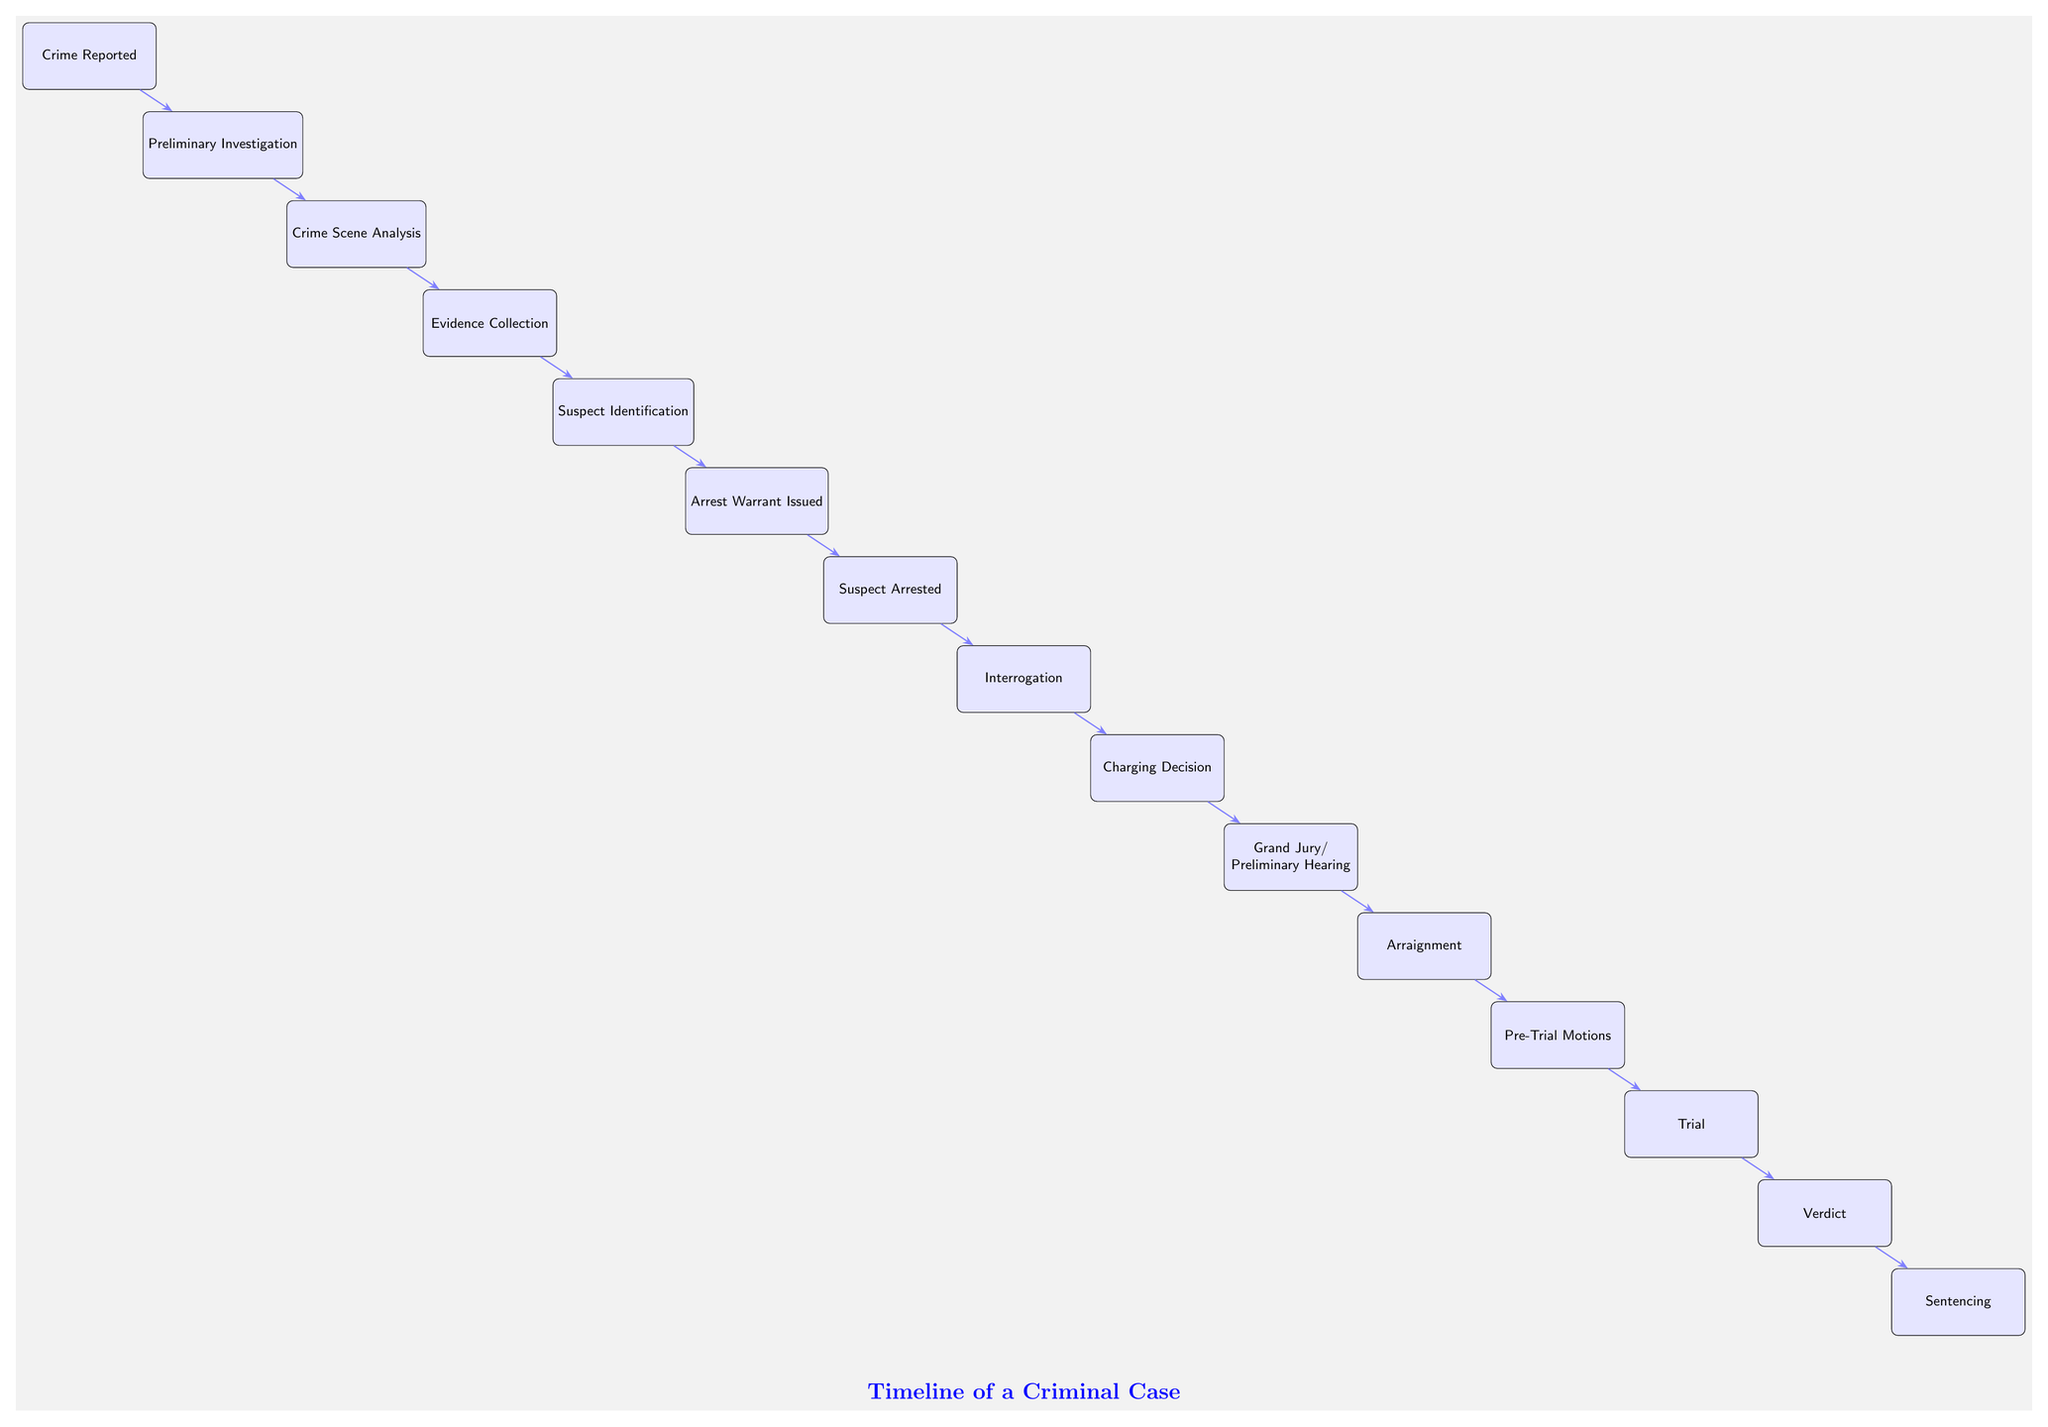What is the first event in the timeline? The first event in the timeline is labeled as "Crime Reported," which is positioned at the top of the diagram.
Answer: Crime Reported How many total events are depicted in the diagram? By counting the total number of events from "Crime Reported" to "Sentencing," we find there are 15 events listed.
Answer: 15 What event follows "Evidence Collection"? The event that follows "Evidence Collection" is "Suspect Identification," as it is directly connected to it in the sequence of the timeline.
Answer: Suspect Identification At what point does the suspect get arrested? The suspect gets arrested after the "Arrest Warrant Issued" event, which means the arrest follows the issuance of a warrant.
Answer: Suspect Arrested What is the last event in the timeline? The last event in the timeline is "Sentencing," which is located at the very bottom of the sequence.
Answer: Sentencing Which event occurs immediately before the trial? "Pre-Trial Motions" occurs immediately before the trial. This shows the steps leading up to the actual trial taking place.
Answer: Pre-Trial Motions How many actions occur between the "Interrogation" and "Verdict"? There are three actions that occur between "Interrogation" and "Verdict," specifically "Charging Decision," "Grand Jury/Preliminary Hearing," and "Arraignment."
Answer: 3 What is the relationship between "Suspect Identification" and "Arrest Warrant Issued"? The relationship is sequential; "Suspect Identification" must occur before "Arrest Warrant Issued" in the investigation process depicted in the timeline.
Answer: Sequential What does the diagram represent? The diagram represents the timeline of a criminal case, detailing each key event from the initiation of the investigation to the final sentencing.
Answer: Timeline of a Criminal Case 